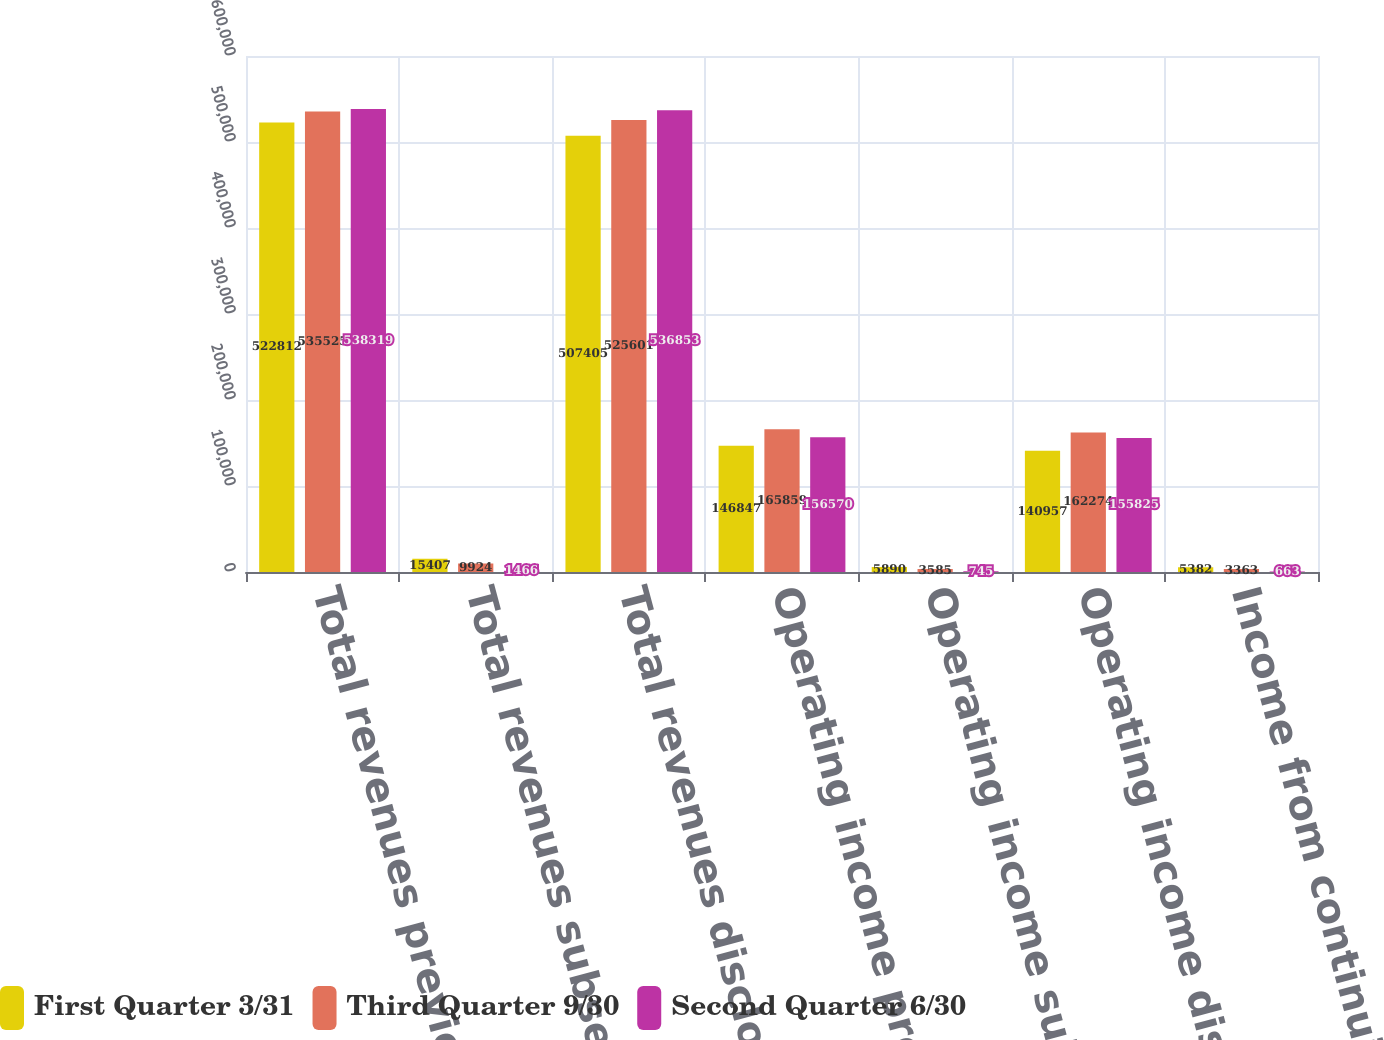<chart> <loc_0><loc_0><loc_500><loc_500><stacked_bar_chart><ecel><fcel>Total revenues previously<fcel>Total revenues subsequently<fcel>Total revenues disclosed in<fcel>Operating income previously<fcel>Operating income subsequently<fcel>Operating income disclosed in<fcel>Income from continuing<nl><fcel>First Quarter 3/31<fcel>522812<fcel>15407<fcel>507405<fcel>146847<fcel>5890<fcel>140957<fcel>5382<nl><fcel>Third Quarter 9/30<fcel>535525<fcel>9924<fcel>525601<fcel>165859<fcel>3585<fcel>162274<fcel>3363<nl><fcel>Second Quarter 6/30<fcel>538319<fcel>1466<fcel>536853<fcel>156570<fcel>745<fcel>155825<fcel>663<nl></chart> 